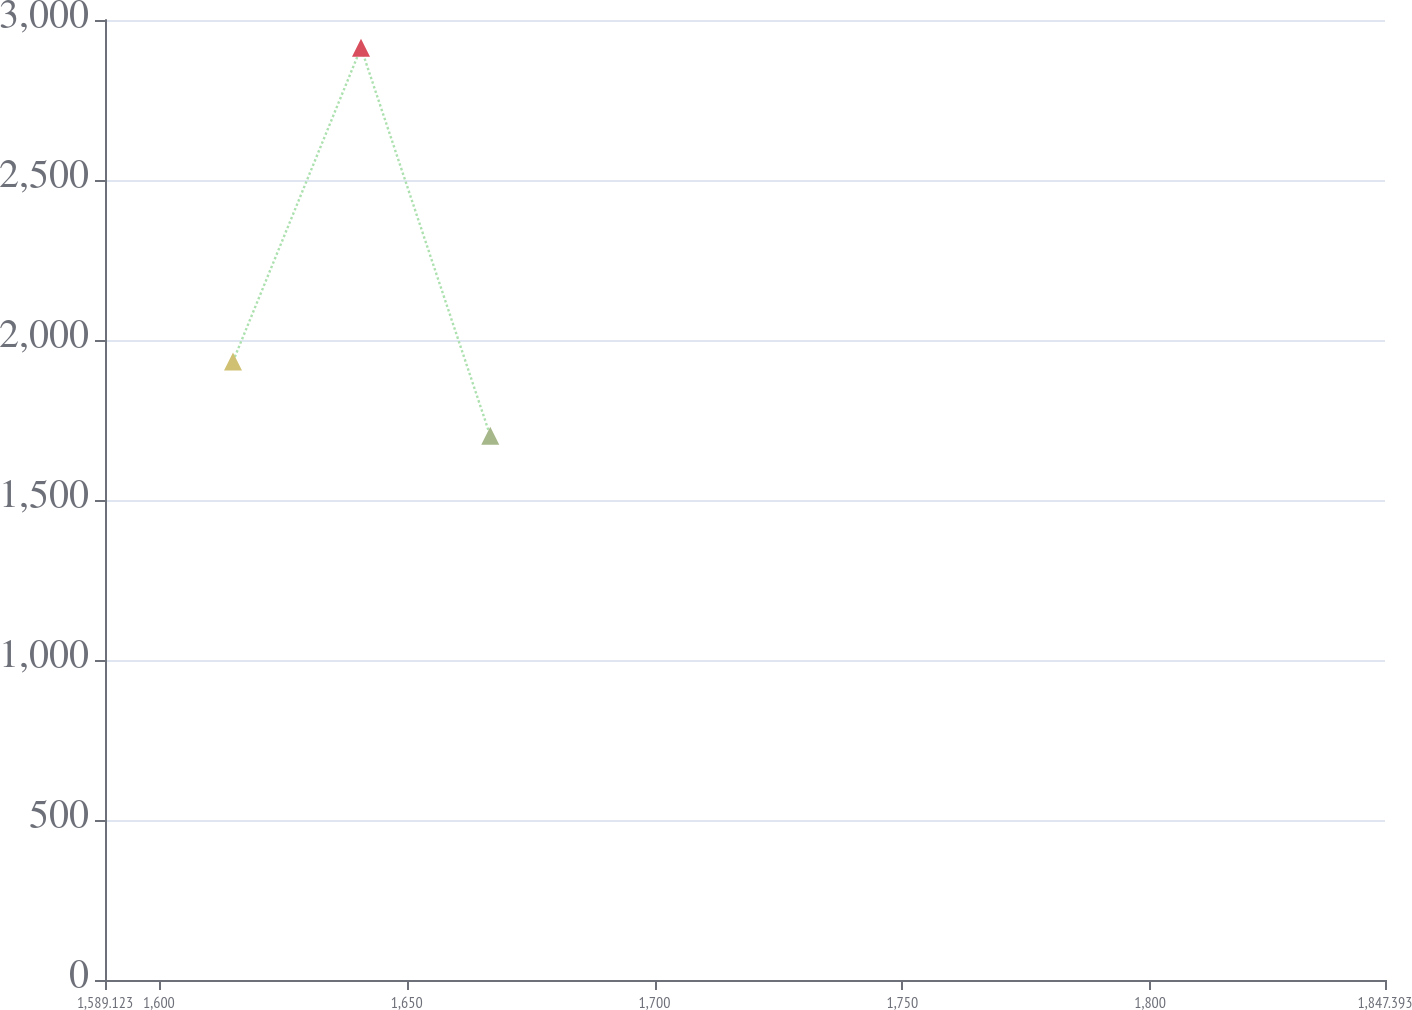Convert chart. <chart><loc_0><loc_0><loc_500><loc_500><line_chart><ecel><fcel>$ 3,341<nl><fcel>1614.95<fcel>1933.07<nl><fcel>1640.78<fcel>2913.42<nl><fcel>1666.86<fcel>1700.75<nl><fcel>1873.22<fcel>1233.8<nl></chart> 